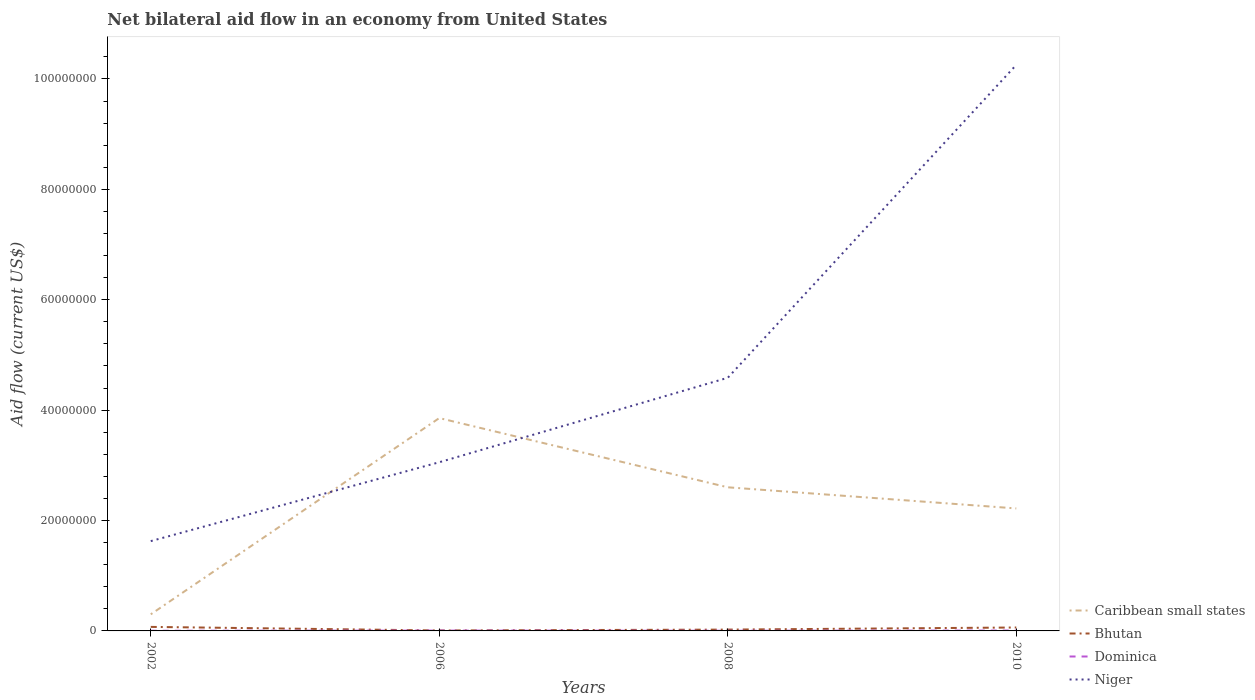Across all years, what is the maximum net bilateral aid flow in Caribbean small states?
Ensure brevity in your answer.  3.01e+06. In which year was the net bilateral aid flow in Niger maximum?
Your answer should be compact. 2002. What is the difference between the highest and the second highest net bilateral aid flow in Niger?
Provide a succinct answer. 8.63e+07. How many lines are there?
Your answer should be compact. 4. What is the difference between two consecutive major ticks on the Y-axis?
Provide a short and direct response. 2.00e+07. Does the graph contain grids?
Your response must be concise. No. How many legend labels are there?
Offer a very short reply. 4. What is the title of the graph?
Offer a very short reply. Net bilateral aid flow in an economy from United States. What is the label or title of the X-axis?
Your answer should be compact. Years. What is the Aid flow (current US$) of Caribbean small states in 2002?
Offer a very short reply. 3.01e+06. What is the Aid flow (current US$) in Bhutan in 2002?
Provide a short and direct response. 7.30e+05. What is the Aid flow (current US$) of Dominica in 2002?
Keep it short and to the point. 3.00e+04. What is the Aid flow (current US$) in Niger in 2002?
Provide a succinct answer. 1.63e+07. What is the Aid flow (current US$) in Caribbean small states in 2006?
Provide a succinct answer. 3.86e+07. What is the Aid flow (current US$) of Niger in 2006?
Your answer should be very brief. 3.06e+07. What is the Aid flow (current US$) of Caribbean small states in 2008?
Ensure brevity in your answer.  2.60e+07. What is the Aid flow (current US$) of Dominica in 2008?
Provide a short and direct response. 3.00e+04. What is the Aid flow (current US$) in Niger in 2008?
Ensure brevity in your answer.  4.59e+07. What is the Aid flow (current US$) in Caribbean small states in 2010?
Keep it short and to the point. 2.22e+07. What is the Aid flow (current US$) in Bhutan in 2010?
Keep it short and to the point. 6.20e+05. What is the Aid flow (current US$) in Dominica in 2010?
Offer a terse response. 7.00e+04. What is the Aid flow (current US$) of Niger in 2010?
Provide a succinct answer. 1.03e+08. Across all years, what is the maximum Aid flow (current US$) of Caribbean small states?
Your response must be concise. 3.86e+07. Across all years, what is the maximum Aid flow (current US$) in Bhutan?
Offer a very short reply. 7.30e+05. Across all years, what is the maximum Aid flow (current US$) of Niger?
Provide a short and direct response. 1.03e+08. Across all years, what is the minimum Aid flow (current US$) in Caribbean small states?
Ensure brevity in your answer.  3.01e+06. Across all years, what is the minimum Aid flow (current US$) in Bhutan?
Ensure brevity in your answer.  8.00e+04. Across all years, what is the minimum Aid flow (current US$) of Dominica?
Your answer should be very brief. 3.00e+04. Across all years, what is the minimum Aid flow (current US$) of Niger?
Provide a succinct answer. 1.63e+07. What is the total Aid flow (current US$) in Caribbean small states in the graph?
Your answer should be very brief. 8.98e+07. What is the total Aid flow (current US$) of Bhutan in the graph?
Offer a very short reply. 1.67e+06. What is the total Aid flow (current US$) in Niger in the graph?
Your response must be concise. 1.95e+08. What is the difference between the Aid flow (current US$) of Caribbean small states in 2002 and that in 2006?
Offer a very short reply. -3.56e+07. What is the difference between the Aid flow (current US$) in Bhutan in 2002 and that in 2006?
Keep it short and to the point. 6.50e+05. What is the difference between the Aid flow (current US$) in Niger in 2002 and that in 2006?
Ensure brevity in your answer.  -1.43e+07. What is the difference between the Aid flow (current US$) in Caribbean small states in 2002 and that in 2008?
Provide a succinct answer. -2.30e+07. What is the difference between the Aid flow (current US$) of Bhutan in 2002 and that in 2008?
Make the answer very short. 4.90e+05. What is the difference between the Aid flow (current US$) of Niger in 2002 and that in 2008?
Make the answer very short. -2.96e+07. What is the difference between the Aid flow (current US$) of Caribbean small states in 2002 and that in 2010?
Offer a terse response. -1.92e+07. What is the difference between the Aid flow (current US$) of Bhutan in 2002 and that in 2010?
Ensure brevity in your answer.  1.10e+05. What is the difference between the Aid flow (current US$) of Dominica in 2002 and that in 2010?
Provide a succinct answer. -4.00e+04. What is the difference between the Aid flow (current US$) in Niger in 2002 and that in 2010?
Provide a succinct answer. -8.63e+07. What is the difference between the Aid flow (current US$) in Caribbean small states in 2006 and that in 2008?
Make the answer very short. 1.25e+07. What is the difference between the Aid flow (current US$) of Bhutan in 2006 and that in 2008?
Your response must be concise. -1.60e+05. What is the difference between the Aid flow (current US$) of Dominica in 2006 and that in 2008?
Make the answer very short. 3.00e+04. What is the difference between the Aid flow (current US$) in Niger in 2006 and that in 2008?
Ensure brevity in your answer.  -1.53e+07. What is the difference between the Aid flow (current US$) in Caribbean small states in 2006 and that in 2010?
Keep it short and to the point. 1.64e+07. What is the difference between the Aid flow (current US$) in Bhutan in 2006 and that in 2010?
Your response must be concise. -5.40e+05. What is the difference between the Aid flow (current US$) in Dominica in 2006 and that in 2010?
Keep it short and to the point. -10000. What is the difference between the Aid flow (current US$) in Niger in 2006 and that in 2010?
Make the answer very short. -7.20e+07. What is the difference between the Aid flow (current US$) in Caribbean small states in 2008 and that in 2010?
Provide a short and direct response. 3.83e+06. What is the difference between the Aid flow (current US$) in Bhutan in 2008 and that in 2010?
Offer a terse response. -3.80e+05. What is the difference between the Aid flow (current US$) in Dominica in 2008 and that in 2010?
Your response must be concise. -4.00e+04. What is the difference between the Aid flow (current US$) in Niger in 2008 and that in 2010?
Provide a succinct answer. -5.67e+07. What is the difference between the Aid flow (current US$) in Caribbean small states in 2002 and the Aid flow (current US$) in Bhutan in 2006?
Give a very brief answer. 2.93e+06. What is the difference between the Aid flow (current US$) of Caribbean small states in 2002 and the Aid flow (current US$) of Dominica in 2006?
Offer a very short reply. 2.95e+06. What is the difference between the Aid flow (current US$) of Caribbean small states in 2002 and the Aid flow (current US$) of Niger in 2006?
Keep it short and to the point. -2.76e+07. What is the difference between the Aid flow (current US$) in Bhutan in 2002 and the Aid flow (current US$) in Dominica in 2006?
Your answer should be very brief. 6.70e+05. What is the difference between the Aid flow (current US$) in Bhutan in 2002 and the Aid flow (current US$) in Niger in 2006?
Your answer should be compact. -2.98e+07. What is the difference between the Aid flow (current US$) in Dominica in 2002 and the Aid flow (current US$) in Niger in 2006?
Your answer should be very brief. -3.05e+07. What is the difference between the Aid flow (current US$) of Caribbean small states in 2002 and the Aid flow (current US$) of Bhutan in 2008?
Your answer should be very brief. 2.77e+06. What is the difference between the Aid flow (current US$) of Caribbean small states in 2002 and the Aid flow (current US$) of Dominica in 2008?
Ensure brevity in your answer.  2.98e+06. What is the difference between the Aid flow (current US$) in Caribbean small states in 2002 and the Aid flow (current US$) in Niger in 2008?
Make the answer very short. -4.28e+07. What is the difference between the Aid flow (current US$) in Bhutan in 2002 and the Aid flow (current US$) in Dominica in 2008?
Offer a terse response. 7.00e+05. What is the difference between the Aid flow (current US$) in Bhutan in 2002 and the Aid flow (current US$) in Niger in 2008?
Offer a terse response. -4.51e+07. What is the difference between the Aid flow (current US$) in Dominica in 2002 and the Aid flow (current US$) in Niger in 2008?
Your response must be concise. -4.58e+07. What is the difference between the Aid flow (current US$) in Caribbean small states in 2002 and the Aid flow (current US$) in Bhutan in 2010?
Your response must be concise. 2.39e+06. What is the difference between the Aid flow (current US$) in Caribbean small states in 2002 and the Aid flow (current US$) in Dominica in 2010?
Provide a short and direct response. 2.94e+06. What is the difference between the Aid flow (current US$) in Caribbean small states in 2002 and the Aid flow (current US$) in Niger in 2010?
Make the answer very short. -9.95e+07. What is the difference between the Aid flow (current US$) in Bhutan in 2002 and the Aid flow (current US$) in Niger in 2010?
Your answer should be compact. -1.02e+08. What is the difference between the Aid flow (current US$) in Dominica in 2002 and the Aid flow (current US$) in Niger in 2010?
Offer a very short reply. -1.03e+08. What is the difference between the Aid flow (current US$) in Caribbean small states in 2006 and the Aid flow (current US$) in Bhutan in 2008?
Keep it short and to the point. 3.83e+07. What is the difference between the Aid flow (current US$) in Caribbean small states in 2006 and the Aid flow (current US$) in Dominica in 2008?
Provide a succinct answer. 3.85e+07. What is the difference between the Aid flow (current US$) in Caribbean small states in 2006 and the Aid flow (current US$) in Niger in 2008?
Provide a short and direct response. -7.30e+06. What is the difference between the Aid flow (current US$) of Bhutan in 2006 and the Aid flow (current US$) of Dominica in 2008?
Keep it short and to the point. 5.00e+04. What is the difference between the Aid flow (current US$) in Bhutan in 2006 and the Aid flow (current US$) in Niger in 2008?
Provide a succinct answer. -4.58e+07. What is the difference between the Aid flow (current US$) of Dominica in 2006 and the Aid flow (current US$) of Niger in 2008?
Your answer should be compact. -4.58e+07. What is the difference between the Aid flow (current US$) of Caribbean small states in 2006 and the Aid flow (current US$) of Bhutan in 2010?
Keep it short and to the point. 3.79e+07. What is the difference between the Aid flow (current US$) in Caribbean small states in 2006 and the Aid flow (current US$) in Dominica in 2010?
Your answer should be very brief. 3.85e+07. What is the difference between the Aid flow (current US$) of Caribbean small states in 2006 and the Aid flow (current US$) of Niger in 2010?
Your answer should be very brief. -6.40e+07. What is the difference between the Aid flow (current US$) of Bhutan in 2006 and the Aid flow (current US$) of Niger in 2010?
Keep it short and to the point. -1.02e+08. What is the difference between the Aid flow (current US$) in Dominica in 2006 and the Aid flow (current US$) in Niger in 2010?
Provide a short and direct response. -1.02e+08. What is the difference between the Aid flow (current US$) in Caribbean small states in 2008 and the Aid flow (current US$) in Bhutan in 2010?
Your response must be concise. 2.54e+07. What is the difference between the Aid flow (current US$) of Caribbean small states in 2008 and the Aid flow (current US$) of Dominica in 2010?
Provide a succinct answer. 2.60e+07. What is the difference between the Aid flow (current US$) in Caribbean small states in 2008 and the Aid flow (current US$) in Niger in 2010?
Your answer should be compact. -7.65e+07. What is the difference between the Aid flow (current US$) of Bhutan in 2008 and the Aid flow (current US$) of Dominica in 2010?
Keep it short and to the point. 1.70e+05. What is the difference between the Aid flow (current US$) in Bhutan in 2008 and the Aid flow (current US$) in Niger in 2010?
Ensure brevity in your answer.  -1.02e+08. What is the difference between the Aid flow (current US$) of Dominica in 2008 and the Aid flow (current US$) of Niger in 2010?
Ensure brevity in your answer.  -1.03e+08. What is the average Aid flow (current US$) of Caribbean small states per year?
Offer a terse response. 2.24e+07. What is the average Aid flow (current US$) of Bhutan per year?
Your answer should be compact. 4.18e+05. What is the average Aid flow (current US$) of Dominica per year?
Provide a short and direct response. 4.75e+04. What is the average Aid flow (current US$) of Niger per year?
Offer a terse response. 4.88e+07. In the year 2002, what is the difference between the Aid flow (current US$) of Caribbean small states and Aid flow (current US$) of Bhutan?
Your response must be concise. 2.28e+06. In the year 2002, what is the difference between the Aid flow (current US$) of Caribbean small states and Aid flow (current US$) of Dominica?
Keep it short and to the point. 2.98e+06. In the year 2002, what is the difference between the Aid flow (current US$) of Caribbean small states and Aid flow (current US$) of Niger?
Provide a succinct answer. -1.33e+07. In the year 2002, what is the difference between the Aid flow (current US$) of Bhutan and Aid flow (current US$) of Niger?
Your answer should be compact. -1.55e+07. In the year 2002, what is the difference between the Aid flow (current US$) in Dominica and Aid flow (current US$) in Niger?
Your answer should be compact. -1.62e+07. In the year 2006, what is the difference between the Aid flow (current US$) in Caribbean small states and Aid flow (current US$) in Bhutan?
Provide a succinct answer. 3.85e+07. In the year 2006, what is the difference between the Aid flow (current US$) in Caribbean small states and Aid flow (current US$) in Dominica?
Make the answer very short. 3.85e+07. In the year 2006, what is the difference between the Aid flow (current US$) in Caribbean small states and Aid flow (current US$) in Niger?
Your answer should be compact. 8.00e+06. In the year 2006, what is the difference between the Aid flow (current US$) of Bhutan and Aid flow (current US$) of Dominica?
Your answer should be very brief. 2.00e+04. In the year 2006, what is the difference between the Aid flow (current US$) in Bhutan and Aid flow (current US$) in Niger?
Your response must be concise. -3.05e+07. In the year 2006, what is the difference between the Aid flow (current US$) in Dominica and Aid flow (current US$) in Niger?
Offer a terse response. -3.05e+07. In the year 2008, what is the difference between the Aid flow (current US$) in Caribbean small states and Aid flow (current US$) in Bhutan?
Make the answer very short. 2.58e+07. In the year 2008, what is the difference between the Aid flow (current US$) in Caribbean small states and Aid flow (current US$) in Dominica?
Your response must be concise. 2.60e+07. In the year 2008, what is the difference between the Aid flow (current US$) in Caribbean small states and Aid flow (current US$) in Niger?
Provide a succinct answer. -1.98e+07. In the year 2008, what is the difference between the Aid flow (current US$) in Bhutan and Aid flow (current US$) in Dominica?
Give a very brief answer. 2.10e+05. In the year 2008, what is the difference between the Aid flow (current US$) in Bhutan and Aid flow (current US$) in Niger?
Give a very brief answer. -4.56e+07. In the year 2008, what is the difference between the Aid flow (current US$) in Dominica and Aid flow (current US$) in Niger?
Keep it short and to the point. -4.58e+07. In the year 2010, what is the difference between the Aid flow (current US$) in Caribbean small states and Aid flow (current US$) in Bhutan?
Give a very brief answer. 2.16e+07. In the year 2010, what is the difference between the Aid flow (current US$) in Caribbean small states and Aid flow (current US$) in Dominica?
Your answer should be compact. 2.21e+07. In the year 2010, what is the difference between the Aid flow (current US$) of Caribbean small states and Aid flow (current US$) of Niger?
Make the answer very short. -8.04e+07. In the year 2010, what is the difference between the Aid flow (current US$) in Bhutan and Aid flow (current US$) in Dominica?
Your response must be concise. 5.50e+05. In the year 2010, what is the difference between the Aid flow (current US$) of Bhutan and Aid flow (current US$) of Niger?
Keep it short and to the point. -1.02e+08. In the year 2010, what is the difference between the Aid flow (current US$) of Dominica and Aid flow (current US$) of Niger?
Provide a short and direct response. -1.02e+08. What is the ratio of the Aid flow (current US$) of Caribbean small states in 2002 to that in 2006?
Your answer should be compact. 0.08. What is the ratio of the Aid flow (current US$) of Bhutan in 2002 to that in 2006?
Keep it short and to the point. 9.12. What is the ratio of the Aid flow (current US$) of Niger in 2002 to that in 2006?
Offer a terse response. 0.53. What is the ratio of the Aid flow (current US$) in Caribbean small states in 2002 to that in 2008?
Offer a very short reply. 0.12. What is the ratio of the Aid flow (current US$) in Bhutan in 2002 to that in 2008?
Provide a short and direct response. 3.04. What is the ratio of the Aid flow (current US$) in Dominica in 2002 to that in 2008?
Your answer should be compact. 1. What is the ratio of the Aid flow (current US$) of Niger in 2002 to that in 2008?
Give a very brief answer. 0.35. What is the ratio of the Aid flow (current US$) of Caribbean small states in 2002 to that in 2010?
Make the answer very short. 0.14. What is the ratio of the Aid flow (current US$) in Bhutan in 2002 to that in 2010?
Provide a short and direct response. 1.18. What is the ratio of the Aid flow (current US$) in Dominica in 2002 to that in 2010?
Your answer should be compact. 0.43. What is the ratio of the Aid flow (current US$) in Niger in 2002 to that in 2010?
Give a very brief answer. 0.16. What is the ratio of the Aid flow (current US$) in Caribbean small states in 2006 to that in 2008?
Keep it short and to the point. 1.48. What is the ratio of the Aid flow (current US$) in Bhutan in 2006 to that in 2008?
Your answer should be compact. 0.33. What is the ratio of the Aid flow (current US$) of Niger in 2006 to that in 2008?
Offer a very short reply. 0.67. What is the ratio of the Aid flow (current US$) of Caribbean small states in 2006 to that in 2010?
Your response must be concise. 1.74. What is the ratio of the Aid flow (current US$) in Bhutan in 2006 to that in 2010?
Ensure brevity in your answer.  0.13. What is the ratio of the Aid flow (current US$) in Dominica in 2006 to that in 2010?
Provide a short and direct response. 0.86. What is the ratio of the Aid flow (current US$) of Niger in 2006 to that in 2010?
Provide a succinct answer. 0.3. What is the ratio of the Aid flow (current US$) of Caribbean small states in 2008 to that in 2010?
Give a very brief answer. 1.17. What is the ratio of the Aid flow (current US$) in Bhutan in 2008 to that in 2010?
Offer a very short reply. 0.39. What is the ratio of the Aid flow (current US$) in Dominica in 2008 to that in 2010?
Offer a terse response. 0.43. What is the ratio of the Aid flow (current US$) in Niger in 2008 to that in 2010?
Provide a succinct answer. 0.45. What is the difference between the highest and the second highest Aid flow (current US$) in Caribbean small states?
Give a very brief answer. 1.25e+07. What is the difference between the highest and the second highest Aid flow (current US$) in Bhutan?
Ensure brevity in your answer.  1.10e+05. What is the difference between the highest and the second highest Aid flow (current US$) in Dominica?
Your response must be concise. 10000. What is the difference between the highest and the second highest Aid flow (current US$) in Niger?
Offer a terse response. 5.67e+07. What is the difference between the highest and the lowest Aid flow (current US$) in Caribbean small states?
Ensure brevity in your answer.  3.56e+07. What is the difference between the highest and the lowest Aid flow (current US$) in Bhutan?
Give a very brief answer. 6.50e+05. What is the difference between the highest and the lowest Aid flow (current US$) of Dominica?
Make the answer very short. 4.00e+04. What is the difference between the highest and the lowest Aid flow (current US$) of Niger?
Make the answer very short. 8.63e+07. 